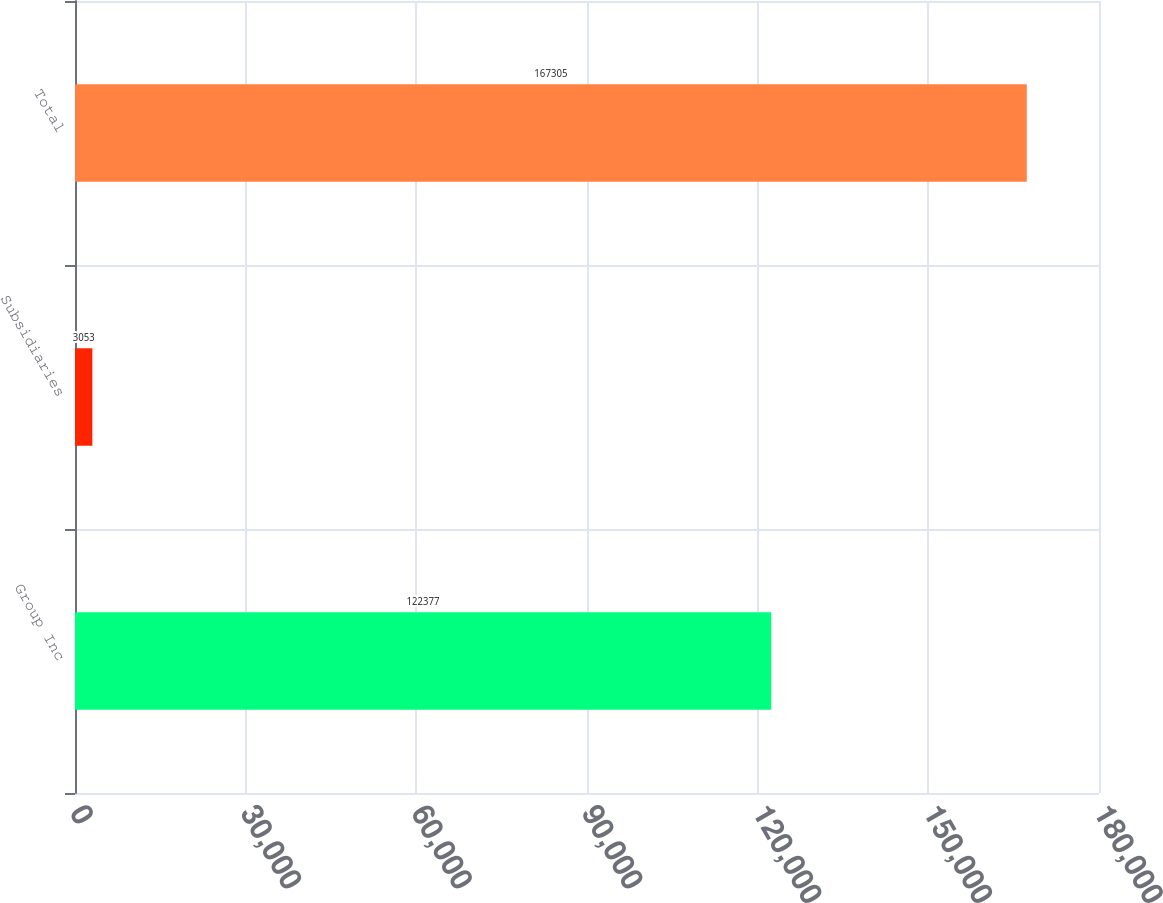Convert chart to OTSL. <chart><loc_0><loc_0><loc_500><loc_500><bar_chart><fcel>Group Inc<fcel>Subsidiaries<fcel>Total<nl><fcel>122377<fcel>3053<fcel>167305<nl></chart> 